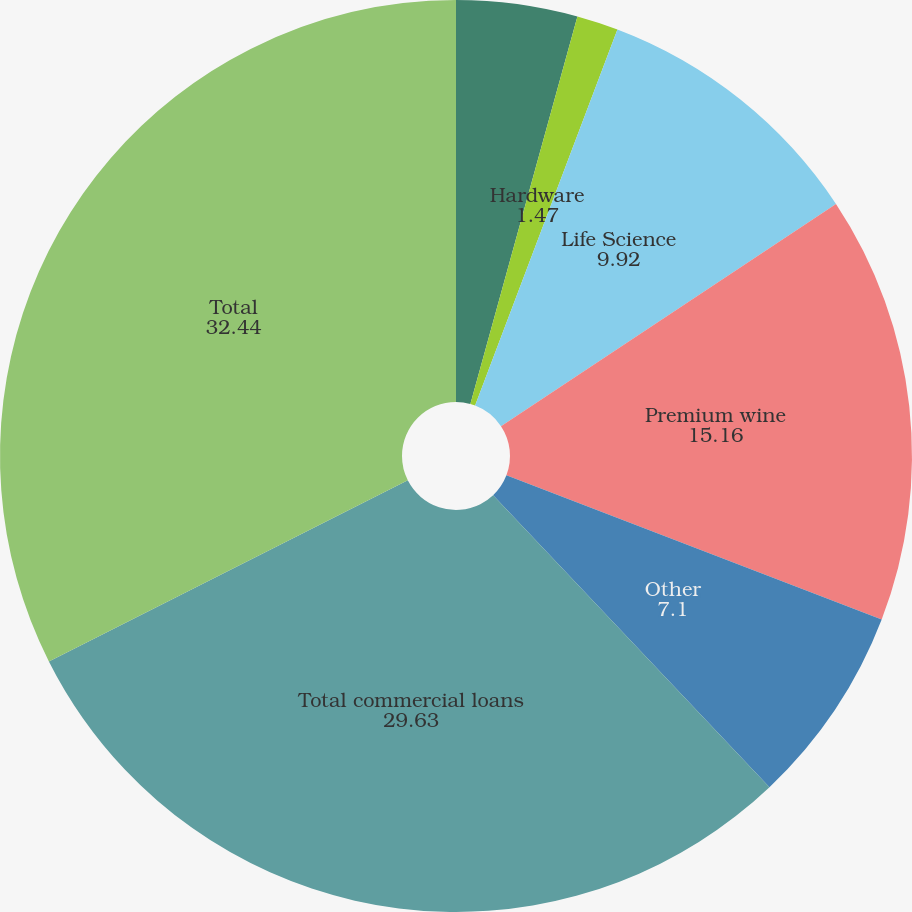Convert chart to OTSL. <chart><loc_0><loc_0><loc_500><loc_500><pie_chart><fcel>Software<fcel>Hardware<fcel>Life Science<fcel>Premium wine<fcel>Other<fcel>Total commercial loans<fcel>Total<nl><fcel>4.29%<fcel>1.47%<fcel>9.92%<fcel>15.16%<fcel>7.1%<fcel>29.63%<fcel>32.44%<nl></chart> 